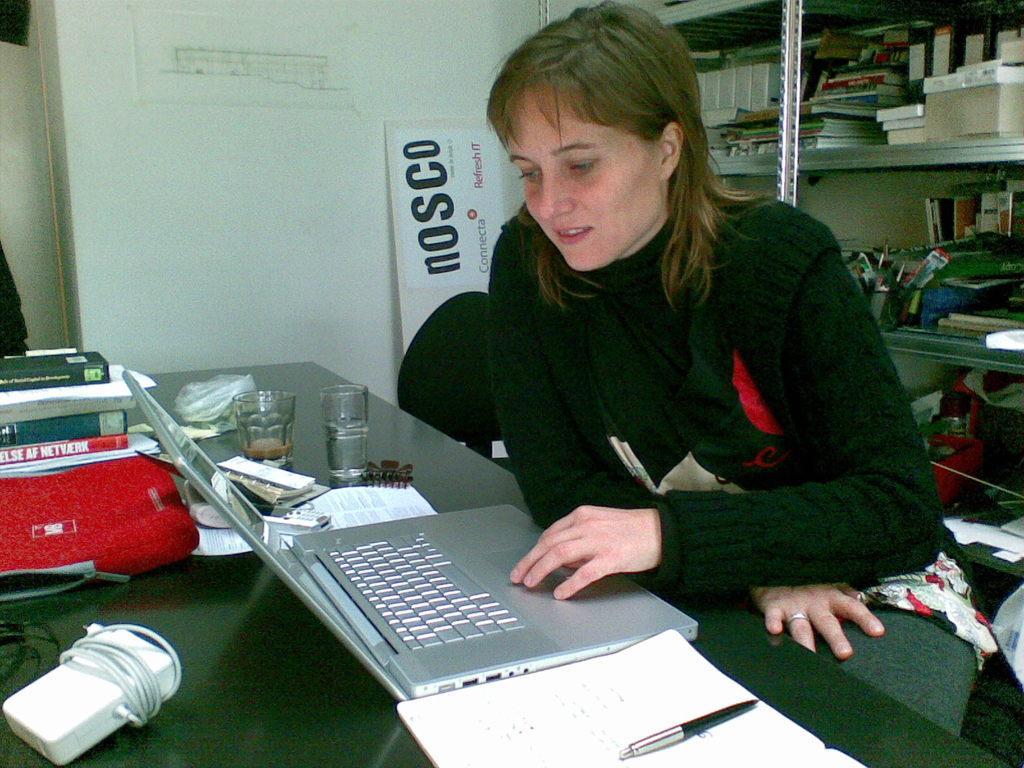In one or two sentences, can you explain what this image depicts? In this image we can see a woman sitting on a chair and a table is placed in front of her. On the table we can see charger, bookbag, glass tumblers, laptop, clip, pen and books. Behind the woman we can see shelf and many things are placed in rows. Beside the woman we can see an advertisement board and wall. 